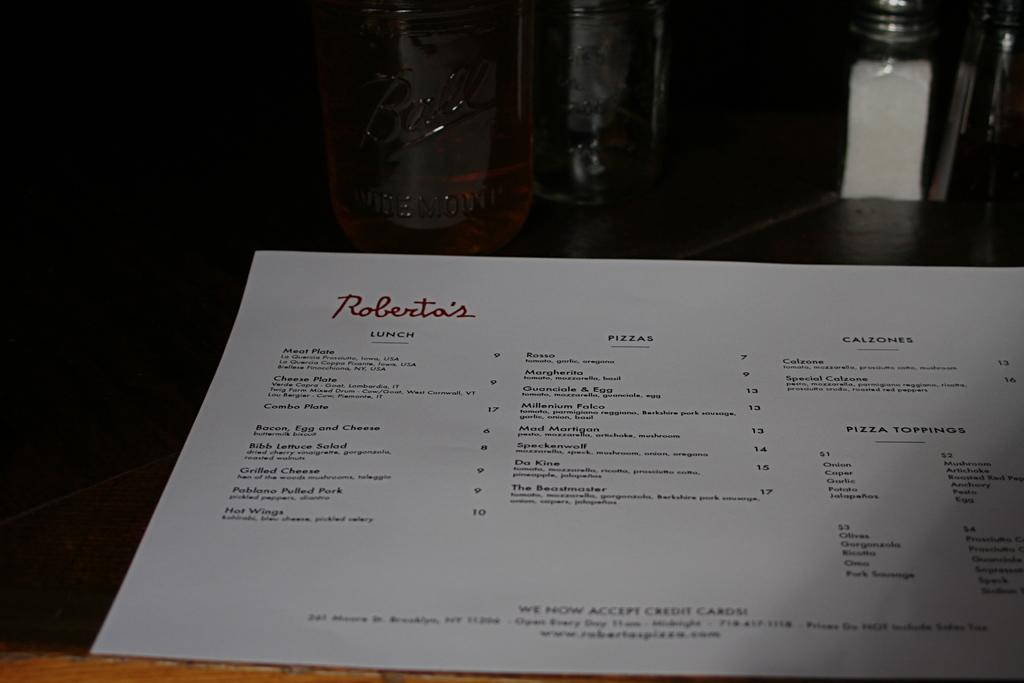<image>
Create a compact narrative representing the image presented. Menu from Roberta's featuring a lunch section and calzones 